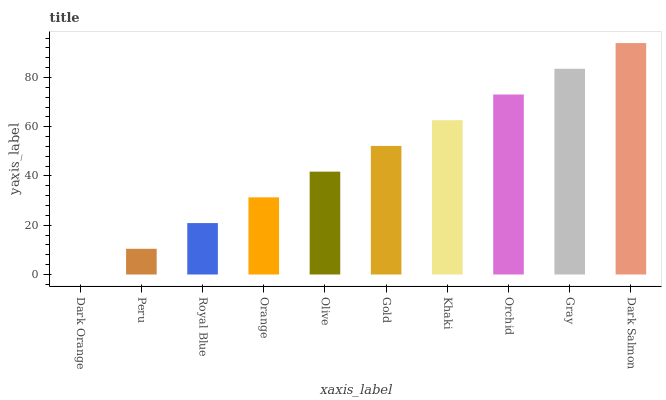Is Dark Orange the minimum?
Answer yes or no. Yes. Is Dark Salmon the maximum?
Answer yes or no. Yes. Is Peru the minimum?
Answer yes or no. No. Is Peru the maximum?
Answer yes or no. No. Is Peru greater than Dark Orange?
Answer yes or no. Yes. Is Dark Orange less than Peru?
Answer yes or no. Yes. Is Dark Orange greater than Peru?
Answer yes or no. No. Is Peru less than Dark Orange?
Answer yes or no. No. Is Gold the high median?
Answer yes or no. Yes. Is Olive the low median?
Answer yes or no. Yes. Is Orange the high median?
Answer yes or no. No. Is Gold the low median?
Answer yes or no. No. 